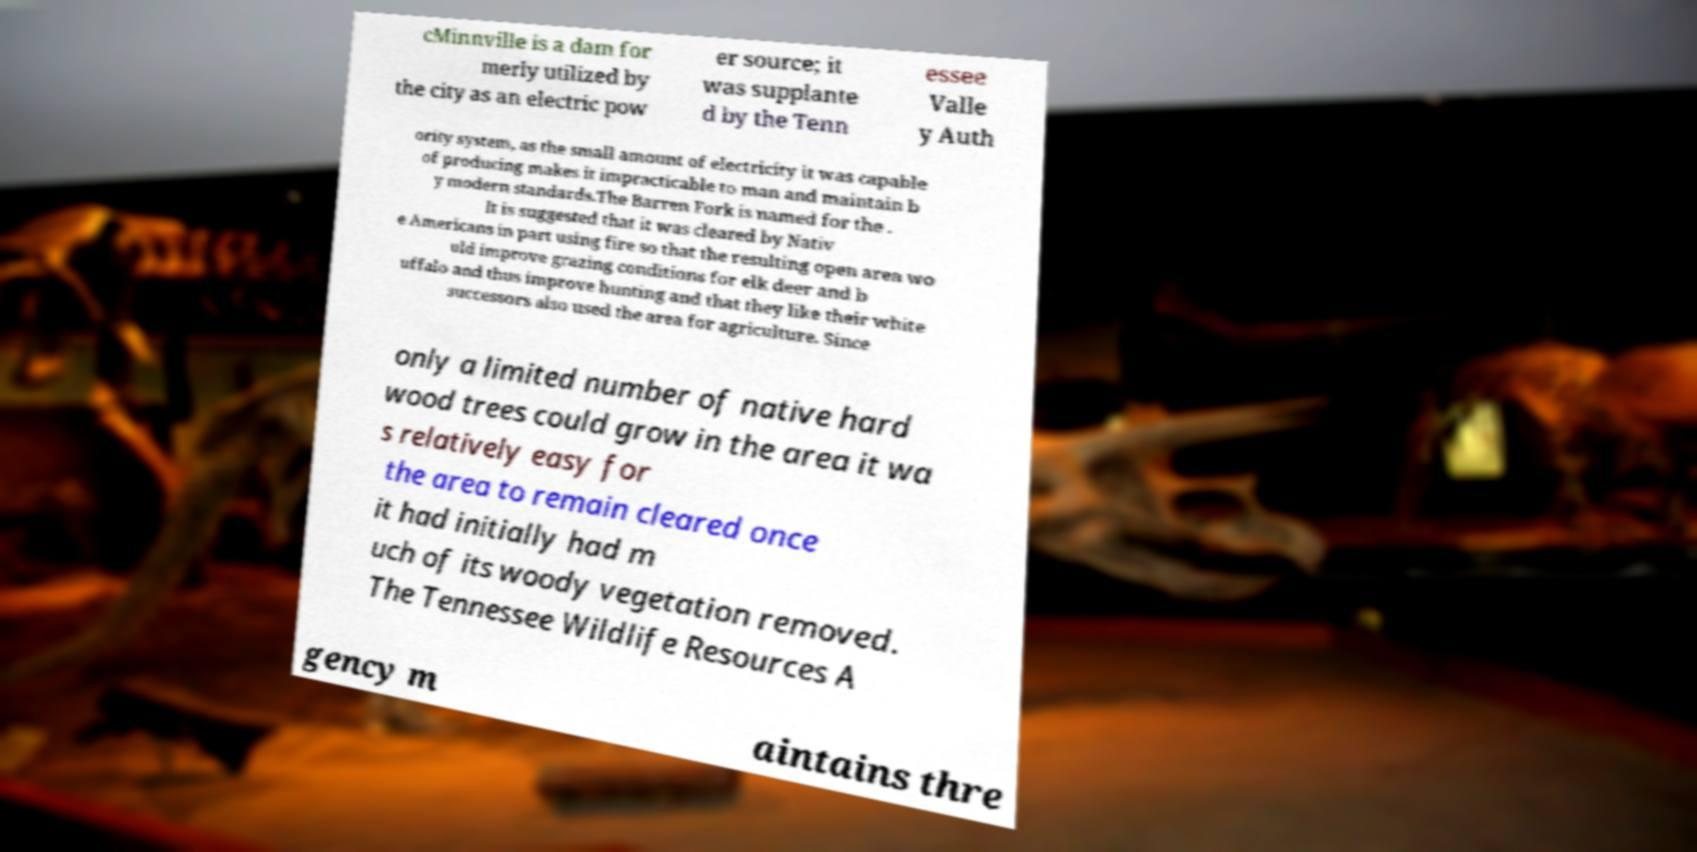There's text embedded in this image that I need extracted. Can you transcribe it verbatim? cMinnville is a dam for merly utilized by the city as an electric pow er source; it was supplante d by the Tenn essee Valle y Auth ority system, as the small amount of electricity it was capable of producing makes it impracticable to man and maintain b y modern standards.The Barren Fork is named for the . It is suggested that it was cleared by Nativ e Americans in part using fire so that the resulting open area wo uld improve grazing conditions for elk deer and b uffalo and thus improve hunting and that they like their white successors also used the area for agriculture. Since only a limited number of native hard wood trees could grow in the area it wa s relatively easy for the area to remain cleared once it had initially had m uch of its woody vegetation removed. The Tennessee Wildlife Resources A gency m aintains thre 